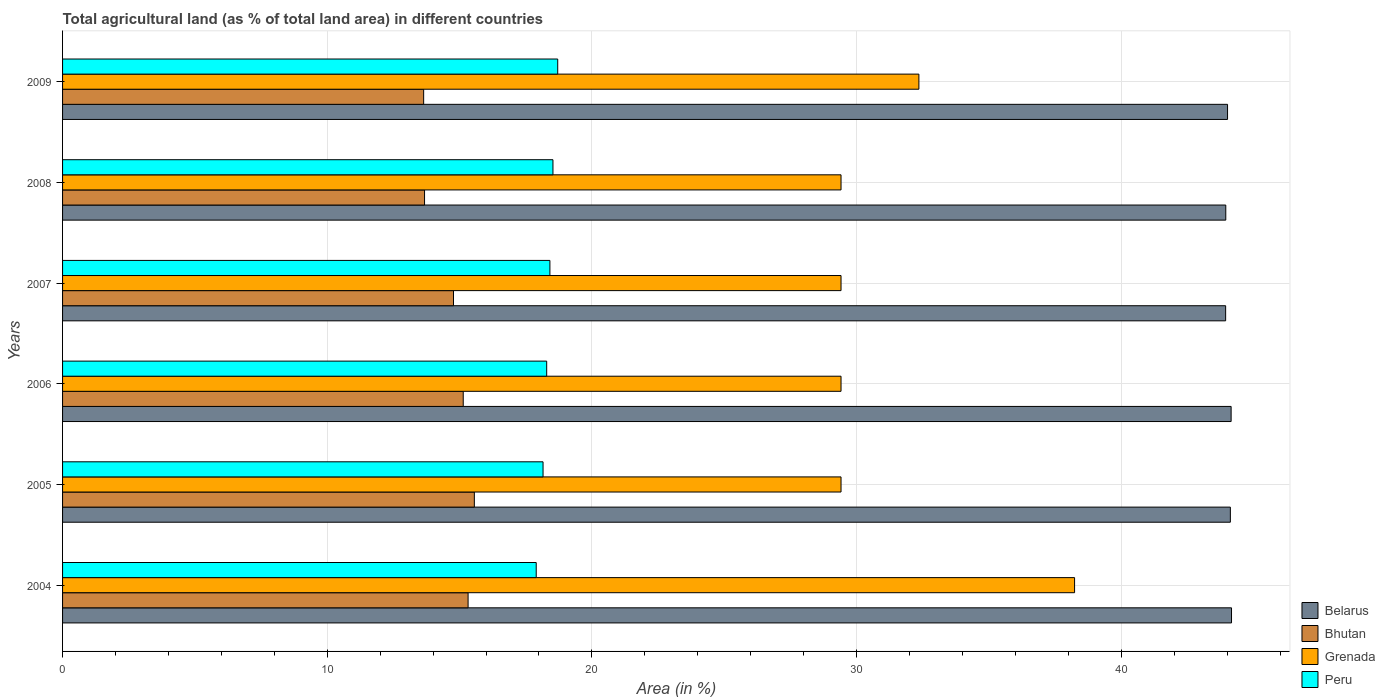How many different coloured bars are there?
Provide a succinct answer. 4. How many bars are there on the 2nd tick from the bottom?
Your answer should be very brief. 4. What is the percentage of agricultural land in Peru in 2007?
Your answer should be compact. 18.41. Across all years, what is the maximum percentage of agricultural land in Grenada?
Your answer should be very brief. 38.24. Across all years, what is the minimum percentage of agricultural land in Bhutan?
Your answer should be compact. 13.64. What is the total percentage of agricultural land in Belarus in the graph?
Make the answer very short. 264.34. What is the difference between the percentage of agricultural land in Peru in 2004 and that in 2006?
Give a very brief answer. -0.4. What is the difference between the percentage of agricultural land in Bhutan in 2009 and the percentage of agricultural land in Grenada in 2007?
Make the answer very short. -15.77. What is the average percentage of agricultural land in Grenada per year?
Offer a terse response. 31.37. In the year 2008, what is the difference between the percentage of agricultural land in Bhutan and percentage of agricultural land in Belarus?
Keep it short and to the point. -30.27. In how many years, is the percentage of agricultural land in Peru greater than 10 %?
Offer a terse response. 6. What is the ratio of the percentage of agricultural land in Belarus in 2004 to that in 2006?
Keep it short and to the point. 1. Is the percentage of agricultural land in Bhutan in 2005 less than that in 2008?
Offer a terse response. No. Is the difference between the percentage of agricultural land in Bhutan in 2004 and 2005 greater than the difference between the percentage of agricultural land in Belarus in 2004 and 2005?
Ensure brevity in your answer.  No. What is the difference between the highest and the second highest percentage of agricultural land in Bhutan?
Your answer should be very brief. 0.24. What is the difference between the highest and the lowest percentage of agricultural land in Grenada?
Make the answer very short. 8.82. What does the 4th bar from the top in 2005 represents?
Provide a short and direct response. Belarus. What does the 3rd bar from the bottom in 2006 represents?
Your answer should be compact. Grenada. Is it the case that in every year, the sum of the percentage of agricultural land in Belarus and percentage of agricultural land in Grenada is greater than the percentage of agricultural land in Bhutan?
Provide a short and direct response. Yes. Does the graph contain grids?
Your answer should be compact. Yes. How many legend labels are there?
Your answer should be compact. 4. What is the title of the graph?
Give a very brief answer. Total agricultural land (as % of total land area) in different countries. What is the label or title of the X-axis?
Provide a short and direct response. Area (in %). What is the Area (in %) of Belarus in 2004?
Provide a short and direct response. 44.16. What is the Area (in %) in Bhutan in 2004?
Keep it short and to the point. 15.32. What is the Area (in %) of Grenada in 2004?
Make the answer very short. 38.24. What is the Area (in %) in Peru in 2004?
Ensure brevity in your answer.  17.9. What is the Area (in %) in Belarus in 2005?
Keep it short and to the point. 44.12. What is the Area (in %) in Bhutan in 2005?
Your answer should be very brief. 15.56. What is the Area (in %) of Grenada in 2005?
Offer a terse response. 29.41. What is the Area (in %) in Peru in 2005?
Ensure brevity in your answer.  18.15. What is the Area (in %) of Belarus in 2006?
Your response must be concise. 44.15. What is the Area (in %) in Bhutan in 2006?
Keep it short and to the point. 15.14. What is the Area (in %) of Grenada in 2006?
Offer a terse response. 29.41. What is the Area (in %) of Peru in 2006?
Your answer should be very brief. 18.29. What is the Area (in %) of Belarus in 2007?
Provide a succinct answer. 43.94. What is the Area (in %) in Bhutan in 2007?
Your answer should be very brief. 14.77. What is the Area (in %) in Grenada in 2007?
Make the answer very short. 29.41. What is the Area (in %) of Peru in 2007?
Provide a succinct answer. 18.41. What is the Area (in %) of Belarus in 2008?
Offer a terse response. 43.95. What is the Area (in %) in Bhutan in 2008?
Ensure brevity in your answer.  13.68. What is the Area (in %) of Grenada in 2008?
Make the answer very short. 29.41. What is the Area (in %) in Peru in 2008?
Your response must be concise. 18.53. What is the Area (in %) in Belarus in 2009?
Make the answer very short. 44.01. What is the Area (in %) in Bhutan in 2009?
Ensure brevity in your answer.  13.64. What is the Area (in %) in Grenada in 2009?
Provide a short and direct response. 32.35. What is the Area (in %) in Peru in 2009?
Provide a succinct answer. 18.71. Across all years, what is the maximum Area (in %) of Belarus?
Give a very brief answer. 44.16. Across all years, what is the maximum Area (in %) in Bhutan?
Provide a succinct answer. 15.56. Across all years, what is the maximum Area (in %) in Grenada?
Provide a short and direct response. 38.24. Across all years, what is the maximum Area (in %) in Peru?
Keep it short and to the point. 18.71. Across all years, what is the minimum Area (in %) of Belarus?
Offer a very short reply. 43.94. Across all years, what is the minimum Area (in %) in Bhutan?
Your answer should be compact. 13.64. Across all years, what is the minimum Area (in %) of Grenada?
Ensure brevity in your answer.  29.41. Across all years, what is the minimum Area (in %) in Peru?
Your response must be concise. 17.9. What is the total Area (in %) in Belarus in the graph?
Give a very brief answer. 264.34. What is the total Area (in %) of Bhutan in the graph?
Offer a terse response. 88.11. What is the total Area (in %) of Grenada in the graph?
Provide a short and direct response. 188.24. What is the total Area (in %) of Peru in the graph?
Your answer should be very brief. 109.99. What is the difference between the Area (in %) in Belarus in 2004 and that in 2005?
Give a very brief answer. 0.04. What is the difference between the Area (in %) in Bhutan in 2004 and that in 2005?
Keep it short and to the point. -0.24. What is the difference between the Area (in %) of Grenada in 2004 and that in 2005?
Your answer should be very brief. 8.82. What is the difference between the Area (in %) in Peru in 2004 and that in 2005?
Keep it short and to the point. -0.26. What is the difference between the Area (in %) in Belarus in 2004 and that in 2006?
Make the answer very short. 0.01. What is the difference between the Area (in %) of Bhutan in 2004 and that in 2006?
Offer a very short reply. 0.18. What is the difference between the Area (in %) of Grenada in 2004 and that in 2006?
Offer a terse response. 8.82. What is the difference between the Area (in %) in Peru in 2004 and that in 2006?
Your answer should be very brief. -0.4. What is the difference between the Area (in %) of Belarus in 2004 and that in 2007?
Your answer should be very brief. 0.22. What is the difference between the Area (in %) of Bhutan in 2004 and that in 2007?
Give a very brief answer. 0.55. What is the difference between the Area (in %) of Grenada in 2004 and that in 2007?
Keep it short and to the point. 8.82. What is the difference between the Area (in %) of Peru in 2004 and that in 2007?
Your answer should be very brief. -0.52. What is the difference between the Area (in %) in Belarus in 2004 and that in 2008?
Keep it short and to the point. 0.22. What is the difference between the Area (in %) of Bhutan in 2004 and that in 2008?
Keep it short and to the point. 1.64. What is the difference between the Area (in %) of Grenada in 2004 and that in 2008?
Provide a short and direct response. 8.82. What is the difference between the Area (in %) in Peru in 2004 and that in 2008?
Provide a short and direct response. -0.63. What is the difference between the Area (in %) in Belarus in 2004 and that in 2009?
Ensure brevity in your answer.  0.15. What is the difference between the Area (in %) of Bhutan in 2004 and that in 2009?
Give a very brief answer. 1.68. What is the difference between the Area (in %) in Grenada in 2004 and that in 2009?
Give a very brief answer. 5.88. What is the difference between the Area (in %) of Peru in 2004 and that in 2009?
Your answer should be compact. -0.81. What is the difference between the Area (in %) in Belarus in 2005 and that in 2006?
Your answer should be very brief. -0.03. What is the difference between the Area (in %) in Bhutan in 2005 and that in 2006?
Provide a succinct answer. 0.42. What is the difference between the Area (in %) in Peru in 2005 and that in 2006?
Ensure brevity in your answer.  -0.14. What is the difference between the Area (in %) in Belarus in 2005 and that in 2007?
Offer a very short reply. 0.18. What is the difference between the Area (in %) in Bhutan in 2005 and that in 2007?
Provide a succinct answer. 0.79. What is the difference between the Area (in %) in Peru in 2005 and that in 2007?
Offer a terse response. -0.26. What is the difference between the Area (in %) of Belarus in 2005 and that in 2008?
Provide a short and direct response. 0.17. What is the difference between the Area (in %) in Bhutan in 2005 and that in 2008?
Offer a terse response. 1.88. What is the difference between the Area (in %) of Grenada in 2005 and that in 2008?
Your response must be concise. 0. What is the difference between the Area (in %) in Peru in 2005 and that in 2008?
Give a very brief answer. -0.37. What is the difference between the Area (in %) of Belarus in 2005 and that in 2009?
Offer a terse response. 0.11. What is the difference between the Area (in %) of Bhutan in 2005 and that in 2009?
Provide a short and direct response. 1.92. What is the difference between the Area (in %) in Grenada in 2005 and that in 2009?
Ensure brevity in your answer.  -2.94. What is the difference between the Area (in %) in Peru in 2005 and that in 2009?
Offer a very short reply. -0.55. What is the difference between the Area (in %) in Belarus in 2006 and that in 2007?
Your response must be concise. 0.21. What is the difference between the Area (in %) of Bhutan in 2006 and that in 2007?
Make the answer very short. 0.37. What is the difference between the Area (in %) in Grenada in 2006 and that in 2007?
Provide a succinct answer. 0. What is the difference between the Area (in %) in Peru in 2006 and that in 2007?
Your answer should be compact. -0.12. What is the difference between the Area (in %) in Belarus in 2006 and that in 2008?
Offer a terse response. 0.2. What is the difference between the Area (in %) in Bhutan in 2006 and that in 2008?
Make the answer very short. 1.46. What is the difference between the Area (in %) in Peru in 2006 and that in 2008?
Your response must be concise. -0.24. What is the difference between the Area (in %) of Belarus in 2006 and that in 2009?
Provide a succinct answer. 0.14. What is the difference between the Area (in %) in Bhutan in 2006 and that in 2009?
Give a very brief answer. 1.5. What is the difference between the Area (in %) of Grenada in 2006 and that in 2009?
Your answer should be very brief. -2.94. What is the difference between the Area (in %) in Peru in 2006 and that in 2009?
Your response must be concise. -0.42. What is the difference between the Area (in %) in Belarus in 2007 and that in 2008?
Offer a very short reply. -0. What is the difference between the Area (in %) of Bhutan in 2007 and that in 2008?
Your answer should be very brief. 1.09. What is the difference between the Area (in %) of Grenada in 2007 and that in 2008?
Offer a very short reply. 0. What is the difference between the Area (in %) in Peru in 2007 and that in 2008?
Keep it short and to the point. -0.11. What is the difference between the Area (in %) in Belarus in 2007 and that in 2009?
Give a very brief answer. -0.07. What is the difference between the Area (in %) in Bhutan in 2007 and that in 2009?
Your response must be concise. 1.13. What is the difference between the Area (in %) in Grenada in 2007 and that in 2009?
Offer a very short reply. -2.94. What is the difference between the Area (in %) of Peru in 2007 and that in 2009?
Offer a very short reply. -0.3. What is the difference between the Area (in %) of Belarus in 2008 and that in 2009?
Keep it short and to the point. -0.07. What is the difference between the Area (in %) in Bhutan in 2008 and that in 2009?
Make the answer very short. 0.03. What is the difference between the Area (in %) of Grenada in 2008 and that in 2009?
Provide a succinct answer. -2.94. What is the difference between the Area (in %) in Peru in 2008 and that in 2009?
Make the answer very short. -0.18. What is the difference between the Area (in %) of Belarus in 2004 and the Area (in %) of Bhutan in 2005?
Your response must be concise. 28.61. What is the difference between the Area (in %) of Belarus in 2004 and the Area (in %) of Grenada in 2005?
Ensure brevity in your answer.  14.75. What is the difference between the Area (in %) in Belarus in 2004 and the Area (in %) in Peru in 2005?
Ensure brevity in your answer.  26.01. What is the difference between the Area (in %) in Bhutan in 2004 and the Area (in %) in Grenada in 2005?
Offer a very short reply. -14.09. What is the difference between the Area (in %) in Bhutan in 2004 and the Area (in %) in Peru in 2005?
Give a very brief answer. -2.83. What is the difference between the Area (in %) of Grenada in 2004 and the Area (in %) of Peru in 2005?
Make the answer very short. 20.08. What is the difference between the Area (in %) in Belarus in 2004 and the Area (in %) in Bhutan in 2006?
Make the answer very short. 29.03. What is the difference between the Area (in %) in Belarus in 2004 and the Area (in %) in Grenada in 2006?
Make the answer very short. 14.75. What is the difference between the Area (in %) of Belarus in 2004 and the Area (in %) of Peru in 2006?
Give a very brief answer. 25.87. What is the difference between the Area (in %) in Bhutan in 2004 and the Area (in %) in Grenada in 2006?
Provide a short and direct response. -14.09. What is the difference between the Area (in %) in Bhutan in 2004 and the Area (in %) in Peru in 2006?
Provide a succinct answer. -2.97. What is the difference between the Area (in %) of Grenada in 2004 and the Area (in %) of Peru in 2006?
Ensure brevity in your answer.  19.94. What is the difference between the Area (in %) in Belarus in 2004 and the Area (in %) in Bhutan in 2007?
Your response must be concise. 29.39. What is the difference between the Area (in %) of Belarus in 2004 and the Area (in %) of Grenada in 2007?
Offer a very short reply. 14.75. What is the difference between the Area (in %) of Belarus in 2004 and the Area (in %) of Peru in 2007?
Offer a terse response. 25.75. What is the difference between the Area (in %) of Bhutan in 2004 and the Area (in %) of Grenada in 2007?
Offer a terse response. -14.09. What is the difference between the Area (in %) of Bhutan in 2004 and the Area (in %) of Peru in 2007?
Ensure brevity in your answer.  -3.09. What is the difference between the Area (in %) of Grenada in 2004 and the Area (in %) of Peru in 2007?
Keep it short and to the point. 19.82. What is the difference between the Area (in %) in Belarus in 2004 and the Area (in %) in Bhutan in 2008?
Provide a succinct answer. 30.49. What is the difference between the Area (in %) in Belarus in 2004 and the Area (in %) in Grenada in 2008?
Provide a short and direct response. 14.75. What is the difference between the Area (in %) in Belarus in 2004 and the Area (in %) in Peru in 2008?
Keep it short and to the point. 25.64. What is the difference between the Area (in %) in Bhutan in 2004 and the Area (in %) in Grenada in 2008?
Your answer should be compact. -14.09. What is the difference between the Area (in %) of Bhutan in 2004 and the Area (in %) of Peru in 2008?
Your response must be concise. -3.21. What is the difference between the Area (in %) of Grenada in 2004 and the Area (in %) of Peru in 2008?
Your answer should be very brief. 19.71. What is the difference between the Area (in %) in Belarus in 2004 and the Area (in %) in Bhutan in 2009?
Keep it short and to the point. 30.52. What is the difference between the Area (in %) of Belarus in 2004 and the Area (in %) of Grenada in 2009?
Your answer should be compact. 11.81. What is the difference between the Area (in %) in Belarus in 2004 and the Area (in %) in Peru in 2009?
Offer a terse response. 25.46. What is the difference between the Area (in %) of Bhutan in 2004 and the Area (in %) of Grenada in 2009?
Ensure brevity in your answer.  -17.03. What is the difference between the Area (in %) of Bhutan in 2004 and the Area (in %) of Peru in 2009?
Keep it short and to the point. -3.39. What is the difference between the Area (in %) in Grenada in 2004 and the Area (in %) in Peru in 2009?
Provide a succinct answer. 19.53. What is the difference between the Area (in %) of Belarus in 2005 and the Area (in %) of Bhutan in 2006?
Your response must be concise. 28.98. What is the difference between the Area (in %) of Belarus in 2005 and the Area (in %) of Grenada in 2006?
Make the answer very short. 14.71. What is the difference between the Area (in %) in Belarus in 2005 and the Area (in %) in Peru in 2006?
Your answer should be very brief. 25.83. What is the difference between the Area (in %) of Bhutan in 2005 and the Area (in %) of Grenada in 2006?
Your answer should be compact. -13.85. What is the difference between the Area (in %) in Bhutan in 2005 and the Area (in %) in Peru in 2006?
Provide a short and direct response. -2.73. What is the difference between the Area (in %) of Grenada in 2005 and the Area (in %) of Peru in 2006?
Ensure brevity in your answer.  11.12. What is the difference between the Area (in %) of Belarus in 2005 and the Area (in %) of Bhutan in 2007?
Keep it short and to the point. 29.35. What is the difference between the Area (in %) of Belarus in 2005 and the Area (in %) of Grenada in 2007?
Ensure brevity in your answer.  14.71. What is the difference between the Area (in %) in Belarus in 2005 and the Area (in %) in Peru in 2007?
Your response must be concise. 25.71. What is the difference between the Area (in %) of Bhutan in 2005 and the Area (in %) of Grenada in 2007?
Offer a terse response. -13.85. What is the difference between the Area (in %) in Bhutan in 2005 and the Area (in %) in Peru in 2007?
Your answer should be very brief. -2.86. What is the difference between the Area (in %) of Grenada in 2005 and the Area (in %) of Peru in 2007?
Provide a succinct answer. 11. What is the difference between the Area (in %) of Belarus in 2005 and the Area (in %) of Bhutan in 2008?
Your answer should be very brief. 30.44. What is the difference between the Area (in %) of Belarus in 2005 and the Area (in %) of Grenada in 2008?
Give a very brief answer. 14.71. What is the difference between the Area (in %) in Belarus in 2005 and the Area (in %) in Peru in 2008?
Ensure brevity in your answer.  25.59. What is the difference between the Area (in %) in Bhutan in 2005 and the Area (in %) in Grenada in 2008?
Give a very brief answer. -13.85. What is the difference between the Area (in %) in Bhutan in 2005 and the Area (in %) in Peru in 2008?
Ensure brevity in your answer.  -2.97. What is the difference between the Area (in %) in Grenada in 2005 and the Area (in %) in Peru in 2008?
Offer a very short reply. 10.88. What is the difference between the Area (in %) in Belarus in 2005 and the Area (in %) in Bhutan in 2009?
Make the answer very short. 30.48. What is the difference between the Area (in %) in Belarus in 2005 and the Area (in %) in Grenada in 2009?
Make the answer very short. 11.77. What is the difference between the Area (in %) in Belarus in 2005 and the Area (in %) in Peru in 2009?
Make the answer very short. 25.41. What is the difference between the Area (in %) in Bhutan in 2005 and the Area (in %) in Grenada in 2009?
Your response must be concise. -16.8. What is the difference between the Area (in %) in Bhutan in 2005 and the Area (in %) in Peru in 2009?
Offer a very short reply. -3.15. What is the difference between the Area (in %) of Grenada in 2005 and the Area (in %) of Peru in 2009?
Ensure brevity in your answer.  10.7. What is the difference between the Area (in %) of Belarus in 2006 and the Area (in %) of Bhutan in 2007?
Offer a very short reply. 29.38. What is the difference between the Area (in %) of Belarus in 2006 and the Area (in %) of Grenada in 2007?
Give a very brief answer. 14.74. What is the difference between the Area (in %) in Belarus in 2006 and the Area (in %) in Peru in 2007?
Ensure brevity in your answer.  25.74. What is the difference between the Area (in %) of Bhutan in 2006 and the Area (in %) of Grenada in 2007?
Offer a very short reply. -14.27. What is the difference between the Area (in %) of Bhutan in 2006 and the Area (in %) of Peru in 2007?
Keep it short and to the point. -3.27. What is the difference between the Area (in %) of Grenada in 2006 and the Area (in %) of Peru in 2007?
Your answer should be compact. 11. What is the difference between the Area (in %) in Belarus in 2006 and the Area (in %) in Bhutan in 2008?
Provide a succinct answer. 30.47. What is the difference between the Area (in %) of Belarus in 2006 and the Area (in %) of Grenada in 2008?
Your response must be concise. 14.74. What is the difference between the Area (in %) of Belarus in 2006 and the Area (in %) of Peru in 2008?
Give a very brief answer. 25.62. What is the difference between the Area (in %) in Bhutan in 2006 and the Area (in %) in Grenada in 2008?
Provide a succinct answer. -14.27. What is the difference between the Area (in %) of Bhutan in 2006 and the Area (in %) of Peru in 2008?
Ensure brevity in your answer.  -3.39. What is the difference between the Area (in %) in Grenada in 2006 and the Area (in %) in Peru in 2008?
Your answer should be very brief. 10.88. What is the difference between the Area (in %) in Belarus in 2006 and the Area (in %) in Bhutan in 2009?
Offer a terse response. 30.51. What is the difference between the Area (in %) of Belarus in 2006 and the Area (in %) of Grenada in 2009?
Ensure brevity in your answer.  11.8. What is the difference between the Area (in %) of Belarus in 2006 and the Area (in %) of Peru in 2009?
Offer a very short reply. 25.44. What is the difference between the Area (in %) in Bhutan in 2006 and the Area (in %) in Grenada in 2009?
Make the answer very short. -17.22. What is the difference between the Area (in %) in Bhutan in 2006 and the Area (in %) in Peru in 2009?
Your answer should be very brief. -3.57. What is the difference between the Area (in %) in Grenada in 2006 and the Area (in %) in Peru in 2009?
Provide a short and direct response. 10.7. What is the difference between the Area (in %) in Belarus in 2007 and the Area (in %) in Bhutan in 2008?
Offer a terse response. 30.27. What is the difference between the Area (in %) in Belarus in 2007 and the Area (in %) in Grenada in 2008?
Keep it short and to the point. 14.53. What is the difference between the Area (in %) in Belarus in 2007 and the Area (in %) in Peru in 2008?
Offer a very short reply. 25.42. What is the difference between the Area (in %) of Bhutan in 2007 and the Area (in %) of Grenada in 2008?
Ensure brevity in your answer.  -14.64. What is the difference between the Area (in %) of Bhutan in 2007 and the Area (in %) of Peru in 2008?
Give a very brief answer. -3.76. What is the difference between the Area (in %) of Grenada in 2007 and the Area (in %) of Peru in 2008?
Your answer should be compact. 10.88. What is the difference between the Area (in %) in Belarus in 2007 and the Area (in %) in Bhutan in 2009?
Your answer should be compact. 30.3. What is the difference between the Area (in %) of Belarus in 2007 and the Area (in %) of Grenada in 2009?
Give a very brief answer. 11.59. What is the difference between the Area (in %) in Belarus in 2007 and the Area (in %) in Peru in 2009?
Your answer should be compact. 25.23. What is the difference between the Area (in %) of Bhutan in 2007 and the Area (in %) of Grenada in 2009?
Your answer should be compact. -17.58. What is the difference between the Area (in %) of Bhutan in 2007 and the Area (in %) of Peru in 2009?
Provide a short and direct response. -3.94. What is the difference between the Area (in %) of Grenada in 2007 and the Area (in %) of Peru in 2009?
Your answer should be very brief. 10.7. What is the difference between the Area (in %) in Belarus in 2008 and the Area (in %) in Bhutan in 2009?
Make the answer very short. 30.31. What is the difference between the Area (in %) of Belarus in 2008 and the Area (in %) of Grenada in 2009?
Make the answer very short. 11.59. What is the difference between the Area (in %) of Belarus in 2008 and the Area (in %) of Peru in 2009?
Provide a succinct answer. 25.24. What is the difference between the Area (in %) of Bhutan in 2008 and the Area (in %) of Grenada in 2009?
Your response must be concise. -18.68. What is the difference between the Area (in %) of Bhutan in 2008 and the Area (in %) of Peru in 2009?
Provide a succinct answer. -5.03. What is the difference between the Area (in %) in Grenada in 2008 and the Area (in %) in Peru in 2009?
Give a very brief answer. 10.7. What is the average Area (in %) of Belarus per year?
Offer a very short reply. 44.06. What is the average Area (in %) in Bhutan per year?
Give a very brief answer. 14.68. What is the average Area (in %) in Grenada per year?
Provide a short and direct response. 31.37. What is the average Area (in %) of Peru per year?
Provide a succinct answer. 18.33. In the year 2004, what is the difference between the Area (in %) of Belarus and Area (in %) of Bhutan?
Make the answer very short. 28.84. In the year 2004, what is the difference between the Area (in %) of Belarus and Area (in %) of Grenada?
Your response must be concise. 5.93. In the year 2004, what is the difference between the Area (in %) of Belarus and Area (in %) of Peru?
Provide a short and direct response. 26.27. In the year 2004, what is the difference between the Area (in %) of Bhutan and Area (in %) of Grenada?
Ensure brevity in your answer.  -22.91. In the year 2004, what is the difference between the Area (in %) in Bhutan and Area (in %) in Peru?
Provide a succinct answer. -2.57. In the year 2004, what is the difference between the Area (in %) in Grenada and Area (in %) in Peru?
Offer a terse response. 20.34. In the year 2005, what is the difference between the Area (in %) in Belarus and Area (in %) in Bhutan?
Offer a terse response. 28.56. In the year 2005, what is the difference between the Area (in %) of Belarus and Area (in %) of Grenada?
Ensure brevity in your answer.  14.71. In the year 2005, what is the difference between the Area (in %) in Belarus and Area (in %) in Peru?
Keep it short and to the point. 25.97. In the year 2005, what is the difference between the Area (in %) of Bhutan and Area (in %) of Grenada?
Ensure brevity in your answer.  -13.85. In the year 2005, what is the difference between the Area (in %) in Bhutan and Area (in %) in Peru?
Keep it short and to the point. -2.6. In the year 2005, what is the difference between the Area (in %) in Grenada and Area (in %) in Peru?
Make the answer very short. 11.26. In the year 2006, what is the difference between the Area (in %) in Belarus and Area (in %) in Bhutan?
Give a very brief answer. 29.01. In the year 2006, what is the difference between the Area (in %) of Belarus and Area (in %) of Grenada?
Offer a terse response. 14.74. In the year 2006, what is the difference between the Area (in %) of Belarus and Area (in %) of Peru?
Provide a short and direct response. 25.86. In the year 2006, what is the difference between the Area (in %) of Bhutan and Area (in %) of Grenada?
Your answer should be very brief. -14.27. In the year 2006, what is the difference between the Area (in %) of Bhutan and Area (in %) of Peru?
Provide a short and direct response. -3.15. In the year 2006, what is the difference between the Area (in %) of Grenada and Area (in %) of Peru?
Ensure brevity in your answer.  11.12. In the year 2007, what is the difference between the Area (in %) of Belarus and Area (in %) of Bhutan?
Your answer should be compact. 29.17. In the year 2007, what is the difference between the Area (in %) in Belarus and Area (in %) in Grenada?
Give a very brief answer. 14.53. In the year 2007, what is the difference between the Area (in %) of Belarus and Area (in %) of Peru?
Provide a short and direct response. 25.53. In the year 2007, what is the difference between the Area (in %) in Bhutan and Area (in %) in Grenada?
Ensure brevity in your answer.  -14.64. In the year 2007, what is the difference between the Area (in %) of Bhutan and Area (in %) of Peru?
Offer a terse response. -3.64. In the year 2007, what is the difference between the Area (in %) of Grenada and Area (in %) of Peru?
Give a very brief answer. 11. In the year 2008, what is the difference between the Area (in %) of Belarus and Area (in %) of Bhutan?
Offer a terse response. 30.27. In the year 2008, what is the difference between the Area (in %) of Belarus and Area (in %) of Grenada?
Keep it short and to the point. 14.54. In the year 2008, what is the difference between the Area (in %) in Belarus and Area (in %) in Peru?
Ensure brevity in your answer.  25.42. In the year 2008, what is the difference between the Area (in %) of Bhutan and Area (in %) of Grenada?
Offer a terse response. -15.74. In the year 2008, what is the difference between the Area (in %) of Bhutan and Area (in %) of Peru?
Provide a succinct answer. -4.85. In the year 2008, what is the difference between the Area (in %) of Grenada and Area (in %) of Peru?
Your answer should be very brief. 10.88. In the year 2009, what is the difference between the Area (in %) in Belarus and Area (in %) in Bhutan?
Your answer should be very brief. 30.37. In the year 2009, what is the difference between the Area (in %) in Belarus and Area (in %) in Grenada?
Your response must be concise. 11.66. In the year 2009, what is the difference between the Area (in %) in Belarus and Area (in %) in Peru?
Give a very brief answer. 25.31. In the year 2009, what is the difference between the Area (in %) in Bhutan and Area (in %) in Grenada?
Your response must be concise. -18.71. In the year 2009, what is the difference between the Area (in %) in Bhutan and Area (in %) in Peru?
Keep it short and to the point. -5.07. In the year 2009, what is the difference between the Area (in %) in Grenada and Area (in %) in Peru?
Your answer should be very brief. 13.65. What is the ratio of the Area (in %) in Grenada in 2004 to that in 2005?
Provide a succinct answer. 1.3. What is the ratio of the Area (in %) of Peru in 2004 to that in 2005?
Offer a terse response. 0.99. What is the ratio of the Area (in %) in Belarus in 2004 to that in 2006?
Provide a succinct answer. 1. What is the ratio of the Area (in %) in Bhutan in 2004 to that in 2006?
Make the answer very short. 1.01. What is the ratio of the Area (in %) in Grenada in 2004 to that in 2006?
Your answer should be very brief. 1.3. What is the ratio of the Area (in %) in Peru in 2004 to that in 2006?
Keep it short and to the point. 0.98. What is the ratio of the Area (in %) in Belarus in 2004 to that in 2007?
Your response must be concise. 1. What is the ratio of the Area (in %) of Bhutan in 2004 to that in 2007?
Give a very brief answer. 1.04. What is the ratio of the Area (in %) in Peru in 2004 to that in 2007?
Ensure brevity in your answer.  0.97. What is the ratio of the Area (in %) in Belarus in 2004 to that in 2008?
Offer a terse response. 1. What is the ratio of the Area (in %) of Bhutan in 2004 to that in 2008?
Offer a very short reply. 1.12. What is the ratio of the Area (in %) of Grenada in 2004 to that in 2008?
Your response must be concise. 1.3. What is the ratio of the Area (in %) of Peru in 2004 to that in 2008?
Offer a terse response. 0.97. What is the ratio of the Area (in %) of Belarus in 2004 to that in 2009?
Offer a terse response. 1. What is the ratio of the Area (in %) of Bhutan in 2004 to that in 2009?
Provide a short and direct response. 1.12. What is the ratio of the Area (in %) of Grenada in 2004 to that in 2009?
Provide a short and direct response. 1.18. What is the ratio of the Area (in %) of Peru in 2004 to that in 2009?
Your response must be concise. 0.96. What is the ratio of the Area (in %) in Belarus in 2005 to that in 2006?
Offer a very short reply. 1. What is the ratio of the Area (in %) in Bhutan in 2005 to that in 2006?
Your response must be concise. 1.03. What is the ratio of the Area (in %) in Grenada in 2005 to that in 2006?
Provide a succinct answer. 1. What is the ratio of the Area (in %) in Peru in 2005 to that in 2006?
Make the answer very short. 0.99. What is the ratio of the Area (in %) in Bhutan in 2005 to that in 2007?
Offer a very short reply. 1.05. What is the ratio of the Area (in %) in Peru in 2005 to that in 2007?
Your response must be concise. 0.99. What is the ratio of the Area (in %) in Belarus in 2005 to that in 2008?
Offer a terse response. 1. What is the ratio of the Area (in %) in Bhutan in 2005 to that in 2008?
Make the answer very short. 1.14. What is the ratio of the Area (in %) of Peru in 2005 to that in 2008?
Your answer should be very brief. 0.98. What is the ratio of the Area (in %) in Bhutan in 2005 to that in 2009?
Ensure brevity in your answer.  1.14. What is the ratio of the Area (in %) of Peru in 2005 to that in 2009?
Provide a succinct answer. 0.97. What is the ratio of the Area (in %) in Bhutan in 2006 to that in 2007?
Make the answer very short. 1.02. What is the ratio of the Area (in %) in Peru in 2006 to that in 2007?
Provide a short and direct response. 0.99. What is the ratio of the Area (in %) of Belarus in 2006 to that in 2008?
Offer a terse response. 1. What is the ratio of the Area (in %) of Bhutan in 2006 to that in 2008?
Provide a short and direct response. 1.11. What is the ratio of the Area (in %) in Peru in 2006 to that in 2008?
Your answer should be very brief. 0.99. What is the ratio of the Area (in %) of Bhutan in 2006 to that in 2009?
Provide a short and direct response. 1.11. What is the ratio of the Area (in %) of Grenada in 2006 to that in 2009?
Make the answer very short. 0.91. What is the ratio of the Area (in %) of Peru in 2006 to that in 2009?
Provide a succinct answer. 0.98. What is the ratio of the Area (in %) of Belarus in 2007 to that in 2008?
Offer a very short reply. 1. What is the ratio of the Area (in %) in Bhutan in 2007 to that in 2008?
Keep it short and to the point. 1.08. What is the ratio of the Area (in %) of Grenada in 2007 to that in 2008?
Keep it short and to the point. 1. What is the ratio of the Area (in %) of Bhutan in 2007 to that in 2009?
Ensure brevity in your answer.  1.08. What is the ratio of the Area (in %) in Grenada in 2007 to that in 2009?
Provide a succinct answer. 0.91. What is the ratio of the Area (in %) in Peru in 2007 to that in 2009?
Make the answer very short. 0.98. What is the ratio of the Area (in %) in Belarus in 2008 to that in 2009?
Your answer should be very brief. 1. What is the ratio of the Area (in %) of Grenada in 2008 to that in 2009?
Provide a succinct answer. 0.91. What is the difference between the highest and the second highest Area (in %) of Belarus?
Give a very brief answer. 0.01. What is the difference between the highest and the second highest Area (in %) of Bhutan?
Give a very brief answer. 0.24. What is the difference between the highest and the second highest Area (in %) in Grenada?
Offer a very short reply. 5.88. What is the difference between the highest and the second highest Area (in %) of Peru?
Provide a short and direct response. 0.18. What is the difference between the highest and the lowest Area (in %) in Belarus?
Your response must be concise. 0.22. What is the difference between the highest and the lowest Area (in %) in Bhutan?
Offer a terse response. 1.92. What is the difference between the highest and the lowest Area (in %) of Grenada?
Your answer should be very brief. 8.82. What is the difference between the highest and the lowest Area (in %) in Peru?
Provide a short and direct response. 0.81. 